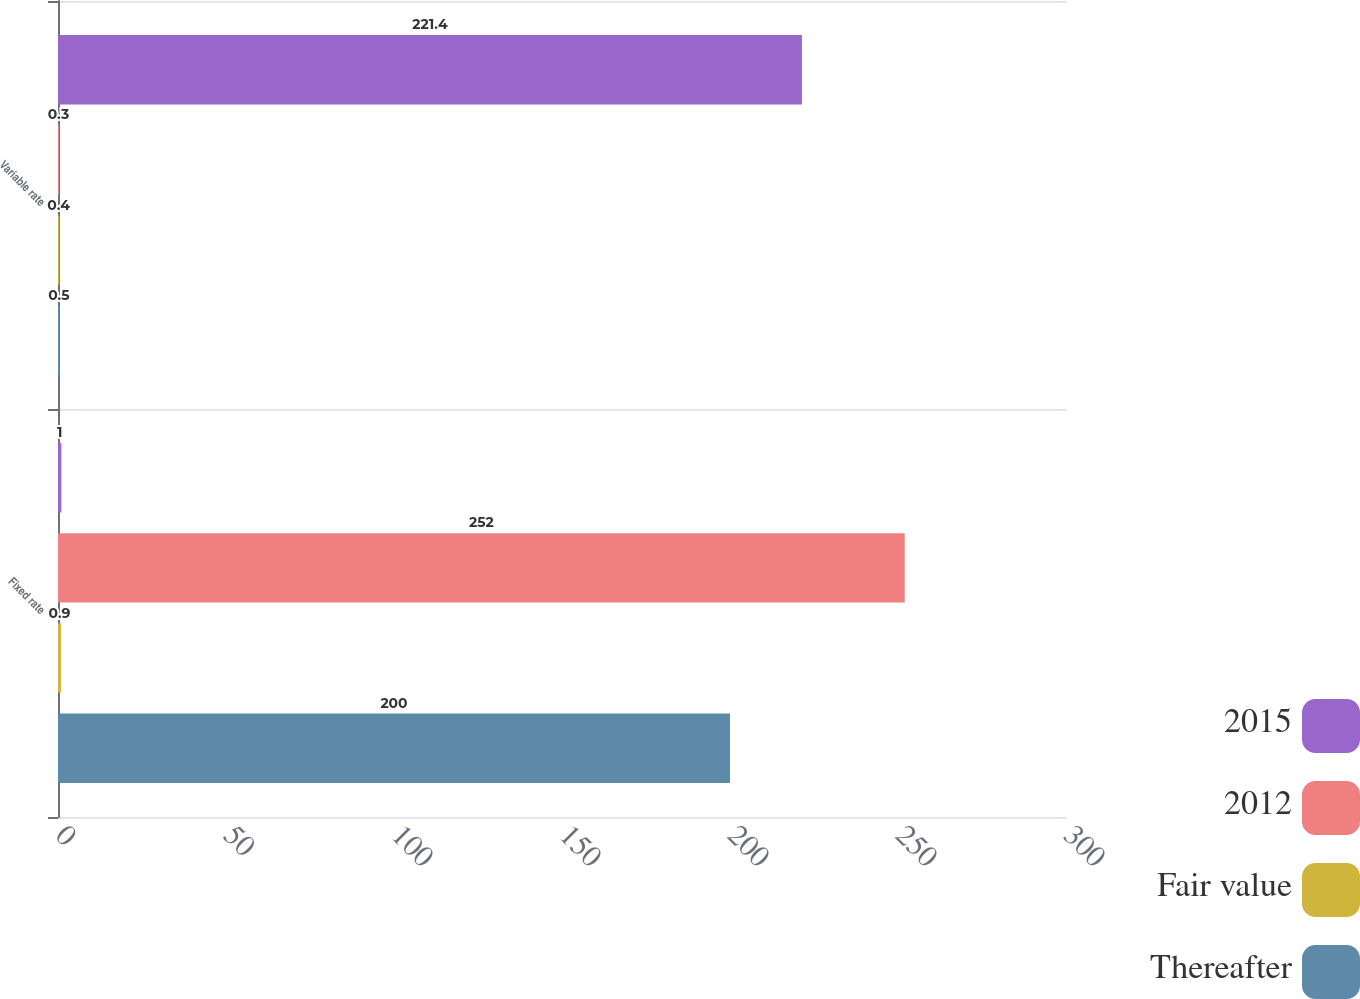<chart> <loc_0><loc_0><loc_500><loc_500><stacked_bar_chart><ecel><fcel>Fixed rate<fcel>Variable rate<nl><fcel>2015<fcel>1<fcel>221.4<nl><fcel>2012<fcel>252<fcel>0.3<nl><fcel>Fair value<fcel>0.9<fcel>0.4<nl><fcel>Thereafter<fcel>200<fcel>0.5<nl></chart> 